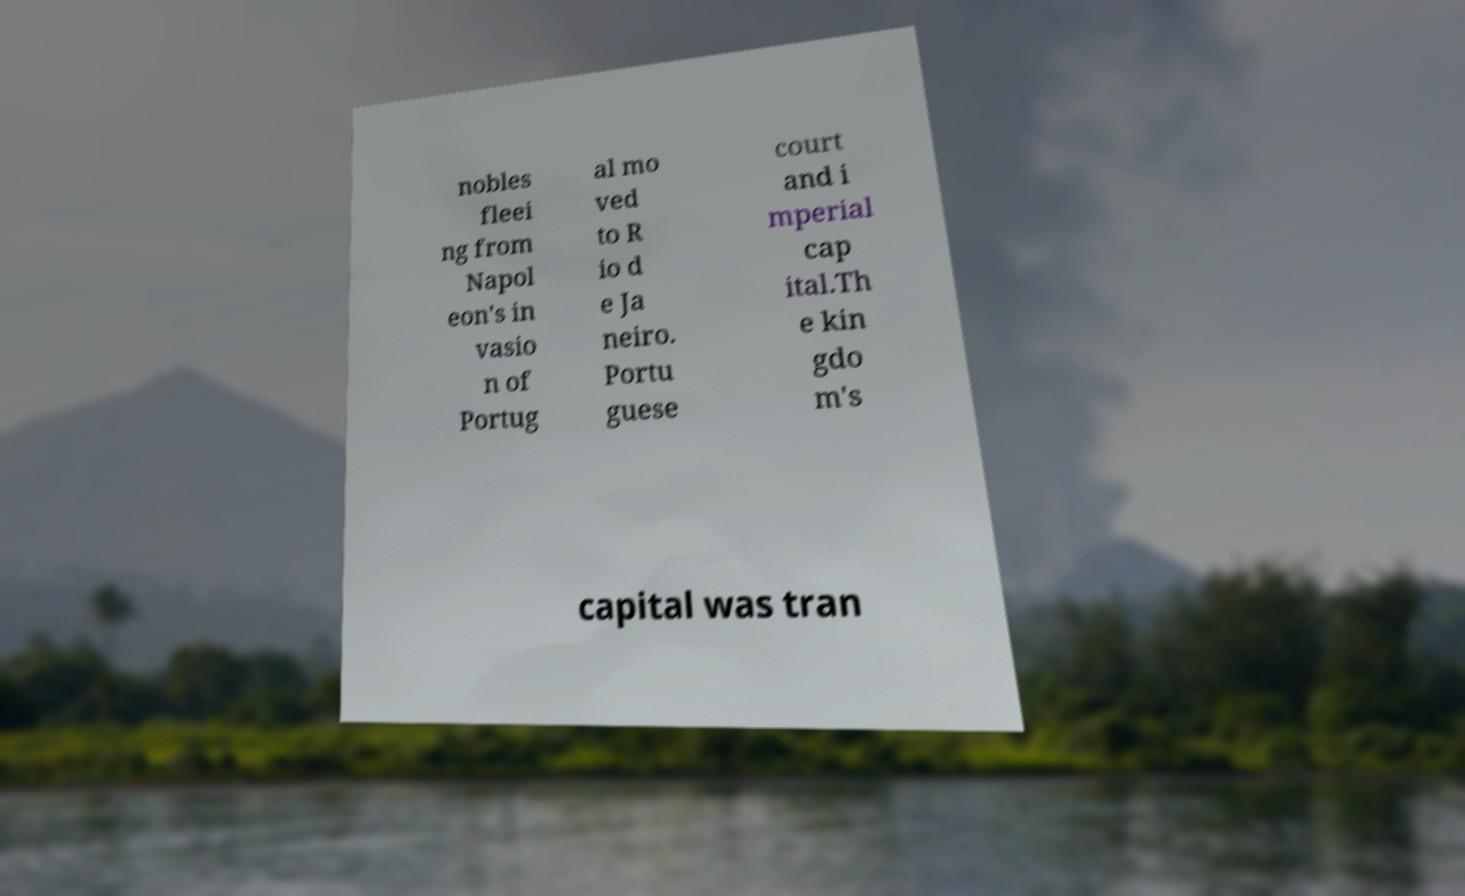Please read and relay the text visible in this image. What does it say? nobles fleei ng from Napol eon's in vasio n of Portug al mo ved to R io d e Ja neiro. Portu guese court and i mperial cap ital.Th e kin gdo m's capital was tran 